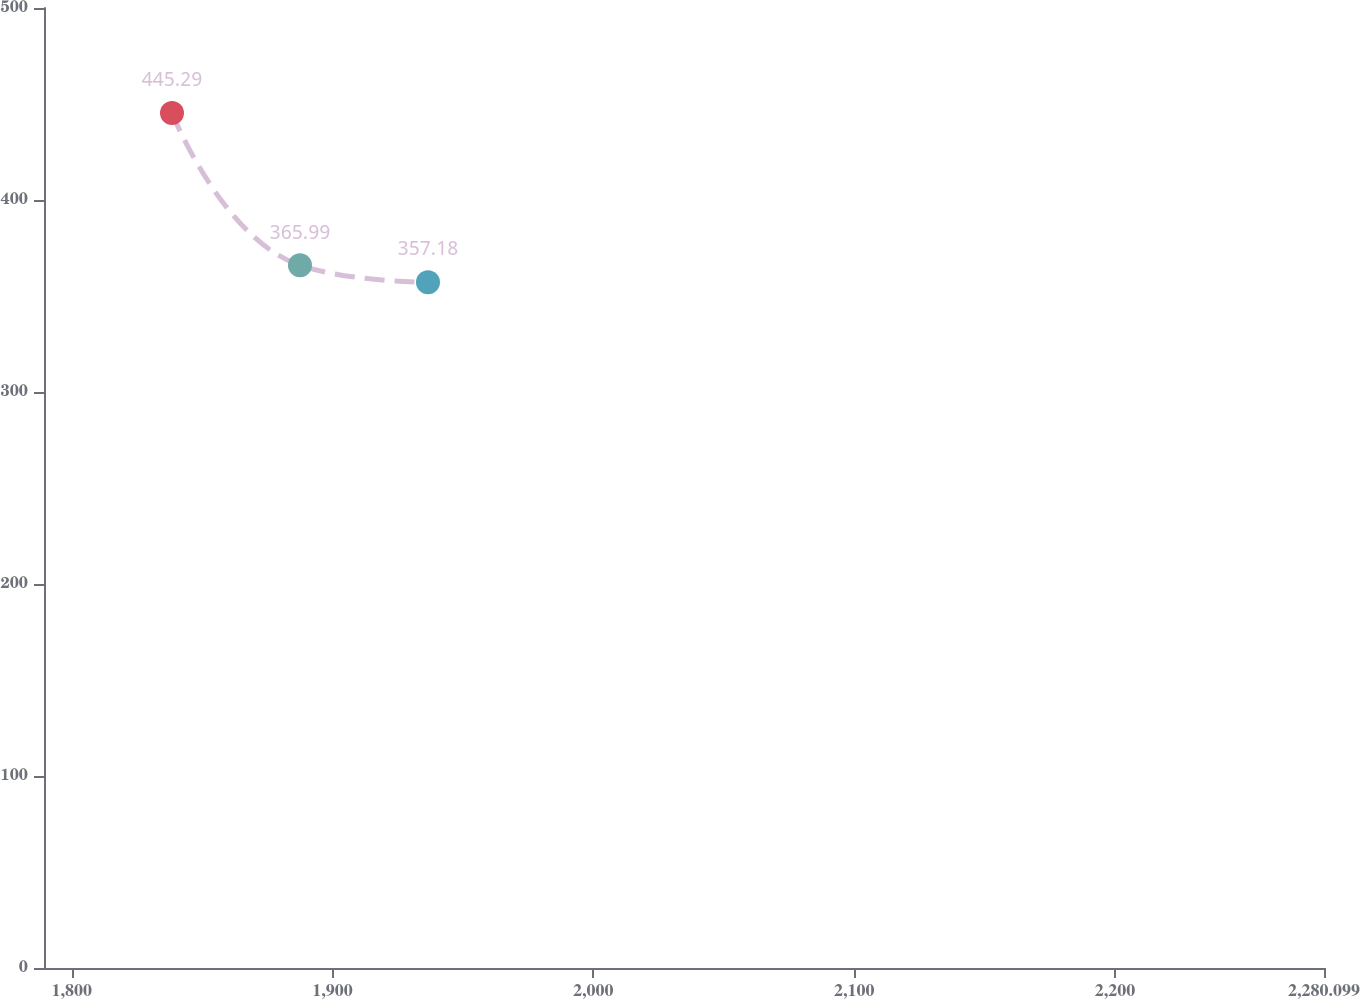Convert chart to OTSL. <chart><loc_0><loc_0><loc_500><loc_500><line_chart><ecel><fcel>$435.6<nl><fcel>1838.46<fcel>445.29<nl><fcel>1887.53<fcel>365.99<nl><fcel>1936.6<fcel>357.18<nl><fcel>2329.17<fcel>426.25<nl></chart> 